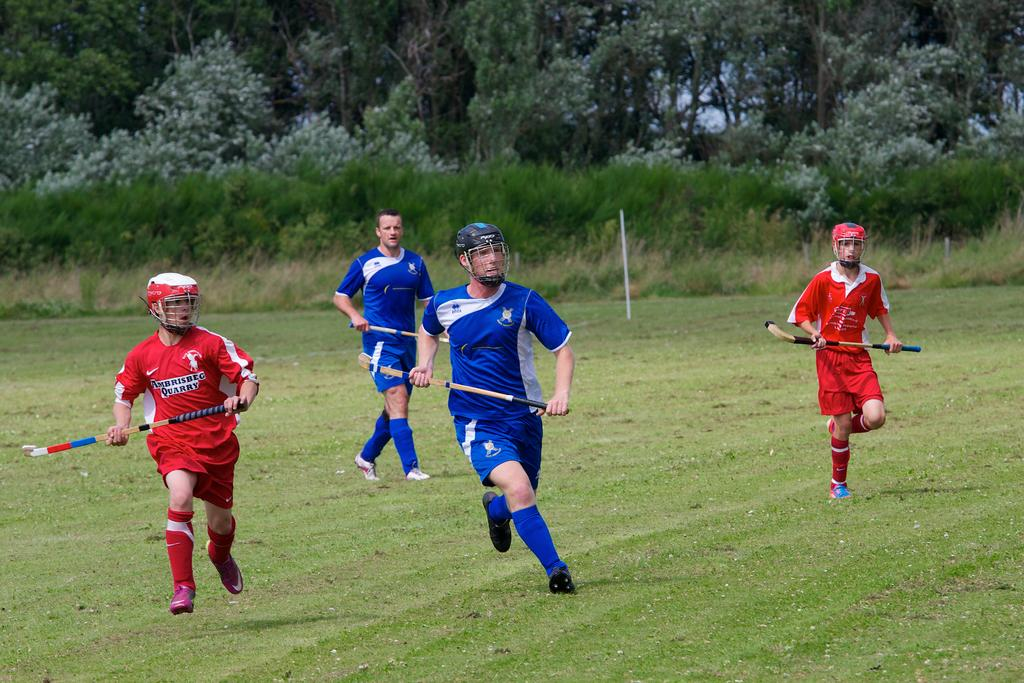<image>
Provide a brief description of the given image. Field Hockey players for Ambrisbec Quarry vie for the ball against another team 